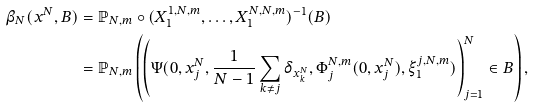Convert formula to latex. <formula><loc_0><loc_0><loc_500><loc_500>\beta _ { N } ( x ^ { N } , B ) & = \mathbb { P } _ { N , m } \circ ( { X } ^ { 1 , N , m } _ { 1 } , \dots , { X } ^ { N , N , m } _ { 1 } ) ^ { - 1 } ( B ) \\ & = \mathbb { P } _ { N , m } \left ( \left ( \Psi ( 0 , x ^ { N } _ { j } , \frac { 1 } { N - 1 } \sum _ { k \neq j } \delta _ { x ^ { N } _ { k } } , \Phi ^ { N , m } _ { j } ( 0 , x ^ { N } _ { j } ) , \xi ^ { j , N , m } _ { 1 } ) \right ) _ { j = 1 } ^ { N } \in B \right ) ,</formula> 